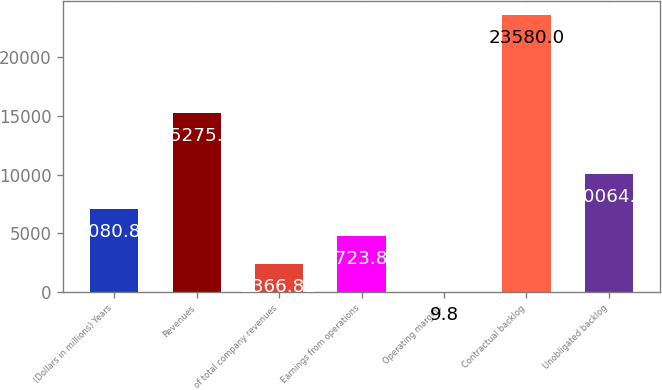Convert chart. <chart><loc_0><loc_0><loc_500><loc_500><bar_chart><fcel>(Dollars in millions) Years<fcel>Revenues<fcel>of total company revenues<fcel>Earnings from operations<fcel>Operating margins<fcel>Contractual backlog<fcel>Unobligated backlog<nl><fcel>7080.86<fcel>15275<fcel>2366.82<fcel>4723.84<fcel>9.8<fcel>23580<fcel>10064<nl></chart> 